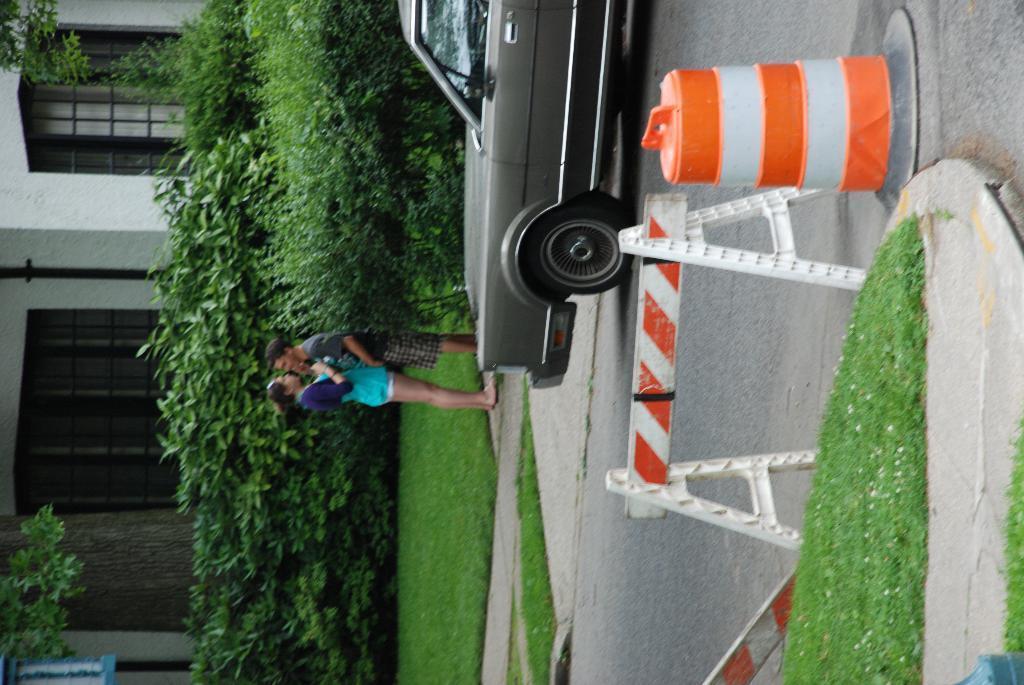Could you give a brief overview of what you see in this image? Bottom left side of the image there are some plants and grass. Behind the plants there is a building. Bottom right side of the image there is grass and there is a fencing and road divider cone. Top right side of the image there is a vehicle on the road. Behind the vehicle there are some plants and two persons are standing. 